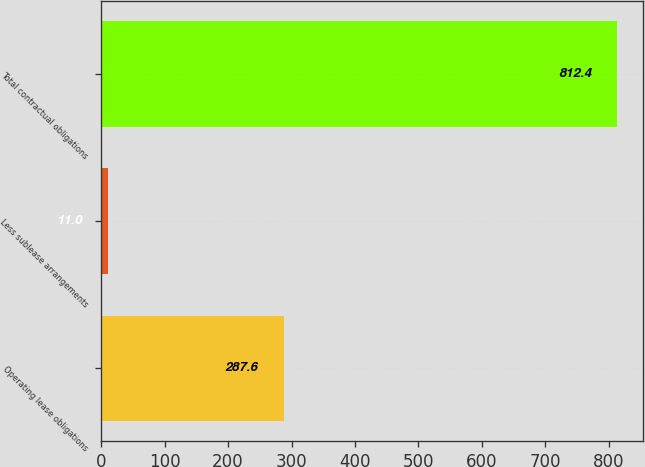Convert chart to OTSL. <chart><loc_0><loc_0><loc_500><loc_500><bar_chart><fcel>Operating lease obligations<fcel>Less sublease arrangements<fcel>Total contractual obligations<nl><fcel>287.6<fcel>11<fcel>812.4<nl></chart> 